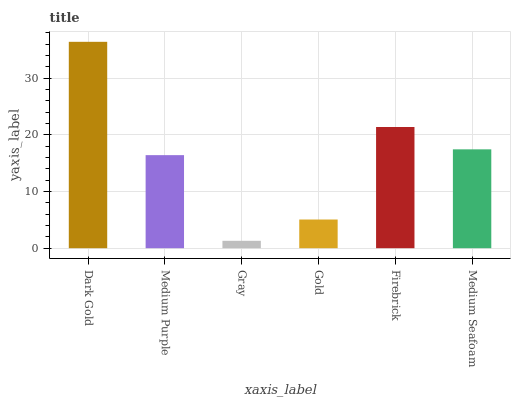Is Gray the minimum?
Answer yes or no. Yes. Is Dark Gold the maximum?
Answer yes or no. Yes. Is Medium Purple the minimum?
Answer yes or no. No. Is Medium Purple the maximum?
Answer yes or no. No. Is Dark Gold greater than Medium Purple?
Answer yes or no. Yes. Is Medium Purple less than Dark Gold?
Answer yes or no. Yes. Is Medium Purple greater than Dark Gold?
Answer yes or no. No. Is Dark Gold less than Medium Purple?
Answer yes or no. No. Is Medium Seafoam the high median?
Answer yes or no. Yes. Is Medium Purple the low median?
Answer yes or no. Yes. Is Gray the high median?
Answer yes or no. No. Is Gold the low median?
Answer yes or no. No. 